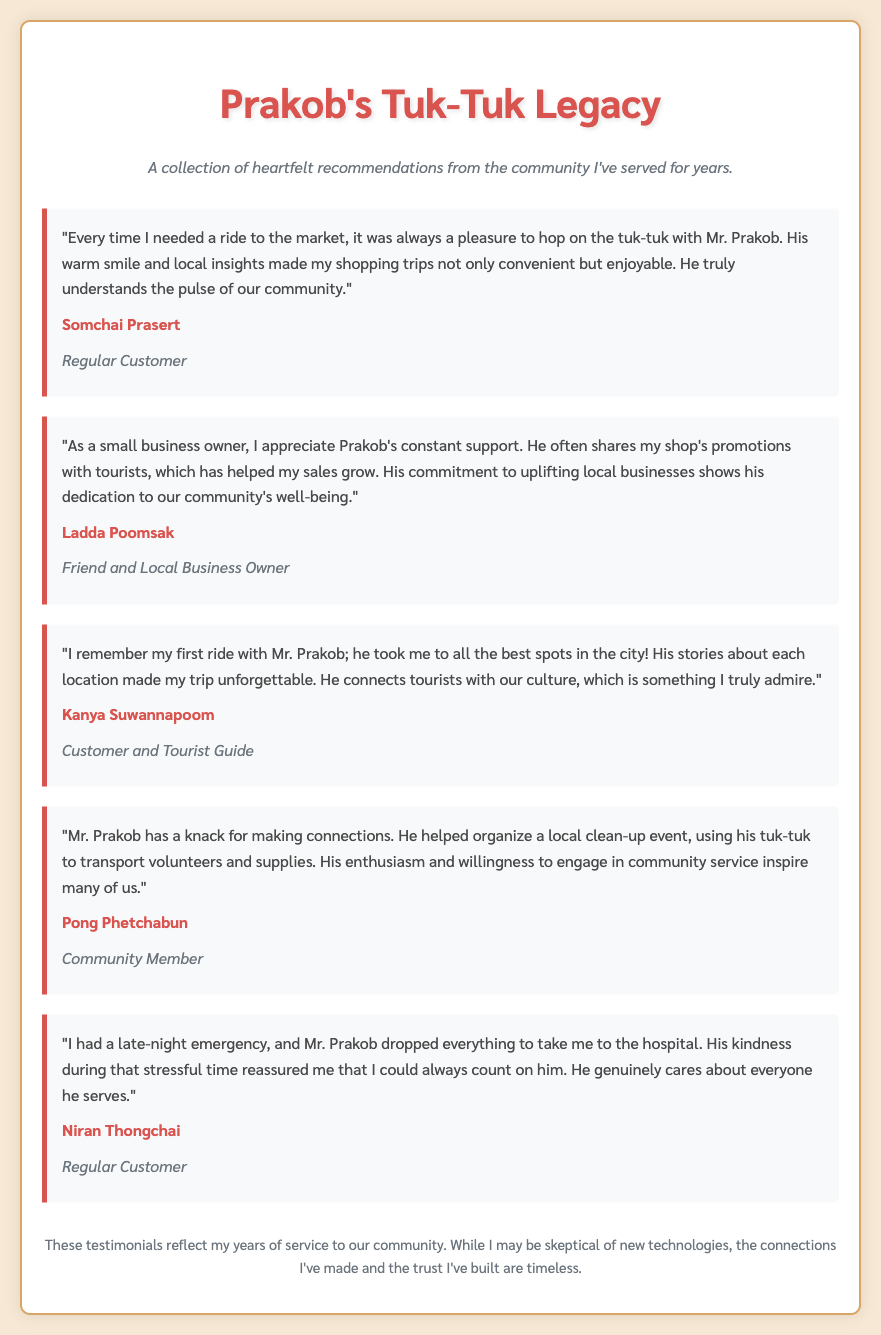What is the title of the document? The title of the document, as indicated in the HTML code, is centered and highlighted as "Prakob's Tuk-Tuk Legacy."
Answer: Prakob's Tuk-Tuk Legacy Who is the first person mentioned in the testimonials? The first person mentioned is recognized in the testimonials section as providing a positive recommendation about Mr. Prakob's services.
Answer: Somchai Prasert What is the relationship of Ladda Poomsak to Mr. Prakob? The document clearly states the connection of Ladda Poomsak to Mr. Prakob in the testimonial section, revealing their mutual connection through business.
Answer: Friend and Local Business Owner What kind of event did Mr. Prakob help organize? The text within the testimonials describes a specific type of community activity that Mr. Prakob engaged in, highlighting his commitment.
Answer: Local clean-up event Which customer experienced an emergency situation? The document recounts a specific instance involving a customer who required urgent assistance from Mr. Prakob, demonstrating his reliability.
Answer: Niran Thongchai How does Mr. Prakob impact local businesses? The text refers to Mr. Prakob's efforts in supporting the local economy by promoting nearby shops to tourists, reflecting his dedication.
Answer: Shares shop's promotions What quality of Mr. Prakob is highlighted by Pong Phetchabun? The document emphasizes a particular trait of Mr. Prakob, showcasing aspects of his character that resonate with community members.
Answer: Enthusiasm How does the document conclude? The final remarks in the text summarize Mr. Prakob's experiences and thoughts on the relationships built throughout his service.
Answer: Trust I've built are timeless 